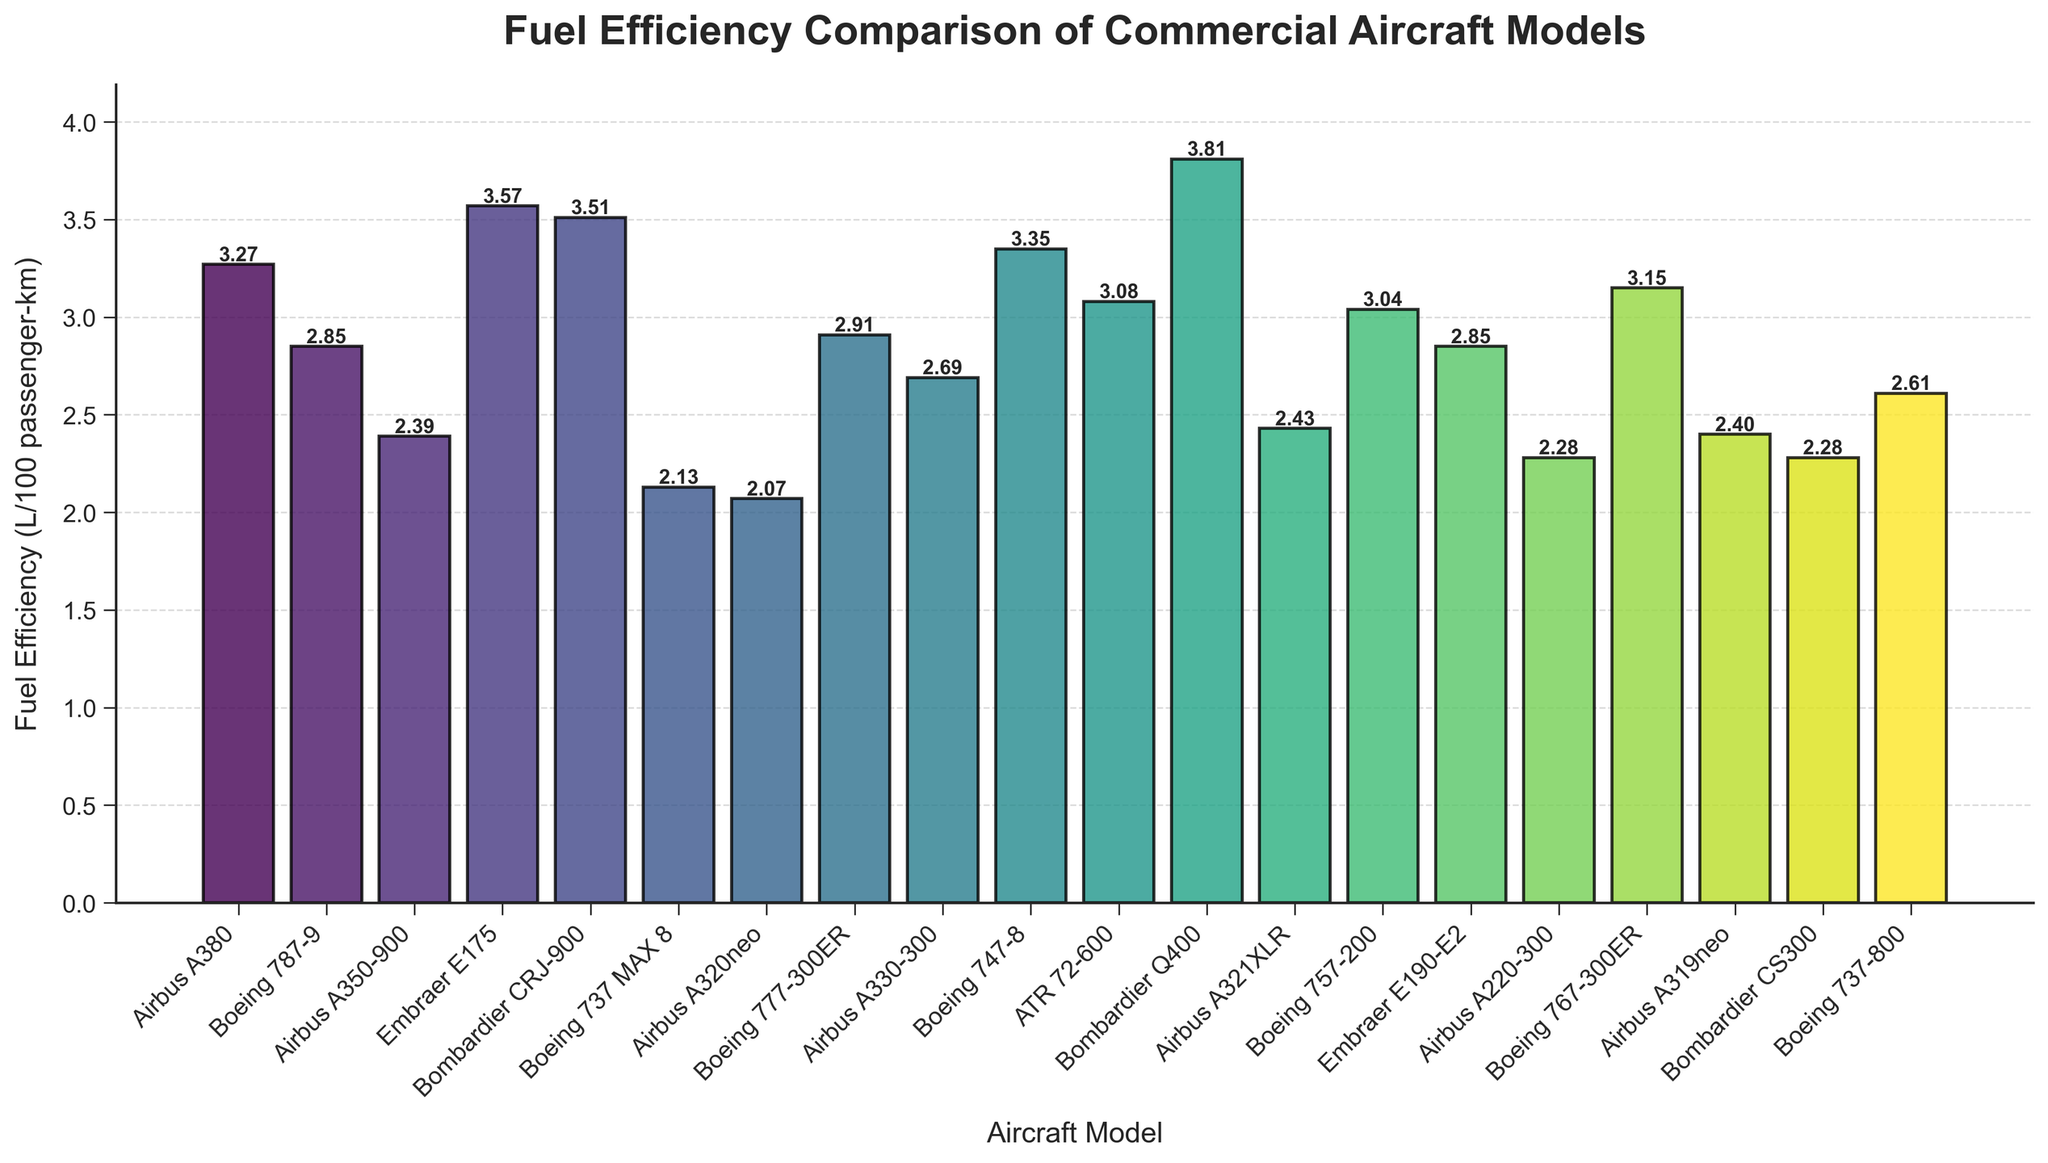Which aircraft model has the highest fuel efficiency? The bars represent the fuel efficiency of different aircraft models. The bar with the lowest height corresponds to the most fuel-efficient model. The Airbus A320neo has the lowest height, which indicates it has the highest fuel efficiency.
Answer: Airbus A320neo Which aircraft model is more fuel efficient: the Airbus A380 or the Boeing 747-8? By comparing the heights of the bars for the Airbus A380 and Boeing 747-8, you can see that the bar for the Airbus A380 is slightly shorter than the bar for the Boeing 747-8. This means the Airbus A380 is more fuel-efficient.
Answer: Airbus A380 What is the average fuel efficiency of the top three most fuel-efficient aircraft models? Identify the three bars with the lowest heights: Airbus A320neo (2.07), Boeing 737 MAX 8 (2.13), and Bombardier CS300 (2.28). The average is calculated as (2.07 + 2.13 + 2.28) / 3.
Answer: 2.16 Which aircraft model has a fuel efficiency closest to 3 L/100 passenger-km? Locate the bar with a height closest to the value of 3. The Boeing 757-200 has a fuel efficiency of 3.04, which is the closest to 3 amongst the listed models.
Answer: Boeing 757-200 How much more fuel-efficient is the Airbus A350-900 compared to the Bombardier Q400? Subtract the fuel efficiency of the Airbus A350-900 (2.39) from that of the Bombardier Q400 (3.81). The difference is 3.81 - 2.39.
Answer: 1.42 How many aircraft models have a fuel efficiency less than 3.00 L/100 passenger-km? Count the number of bars with heights less than the threshold of 3.00. The following models meet this criterion: Boeing 787-9, Airbus A350-900, Boeing 737 MAX 8, Airbus A320neo, Boeing 777-300ER, Airbus A330-300, Airbus A321XLR, Embraer E190-E2, Airbus A220-300, Airbus A319neo, Bombardier CS300, Boeing 737-800. In total, there are 12 models.
Answer: 12 Is the Boeing 787-9 more or less fuel efficient than the Embraer E190-E2? Compare the bar heights for the Boeing 787-9 and Embraer E190-E2. The heights are equal, indicating that their fuel efficiencies are the same.
Answer: Equal What's the difference in fuel efficiency between the most and least fuel-efficient aircraft models? Determine the extreme values: Airbus A320neo at 2.07 (most efficient) and Bombardier Q400 at 3.81 (least efficient). The difference is 3.81 - 2.07.
Answer: 1.74 Which model is the least fuel-efficient? The bar with the greatest height corresponds to the least fuel-efficient model. The bar for the Bombardier Q400 has the highest height.
Answer: Bombardier Q400 